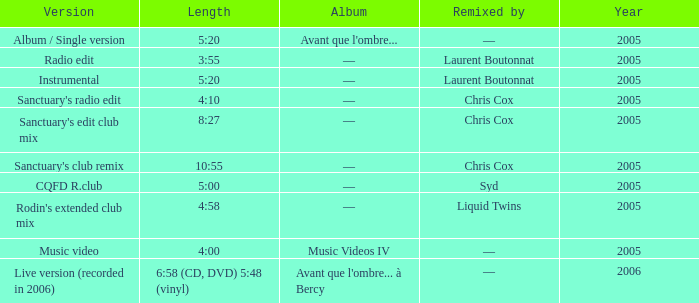What is the version shown for the Length of 5:20, and shows Remixed by —? Album / Single version. 